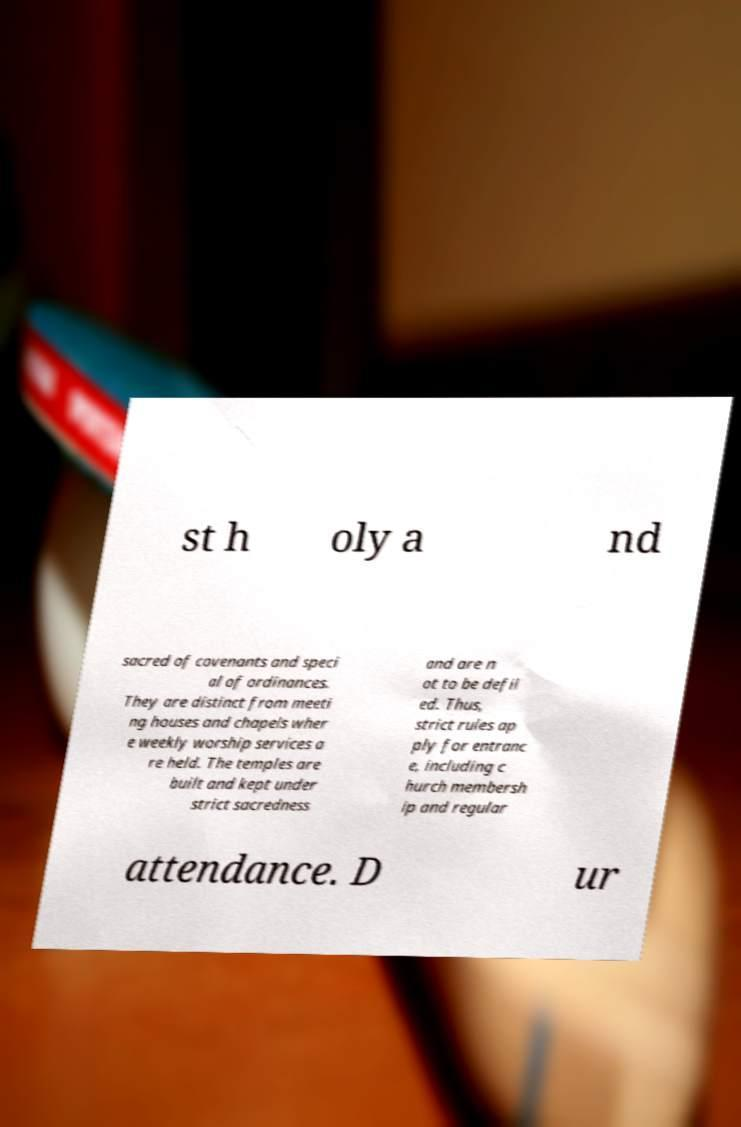Could you assist in decoding the text presented in this image and type it out clearly? st h oly a nd sacred of covenants and speci al of ordinances. They are distinct from meeti ng houses and chapels wher e weekly worship services a re held. The temples are built and kept under strict sacredness and are n ot to be defil ed. Thus, strict rules ap ply for entranc e, including c hurch membersh ip and regular attendance. D ur 